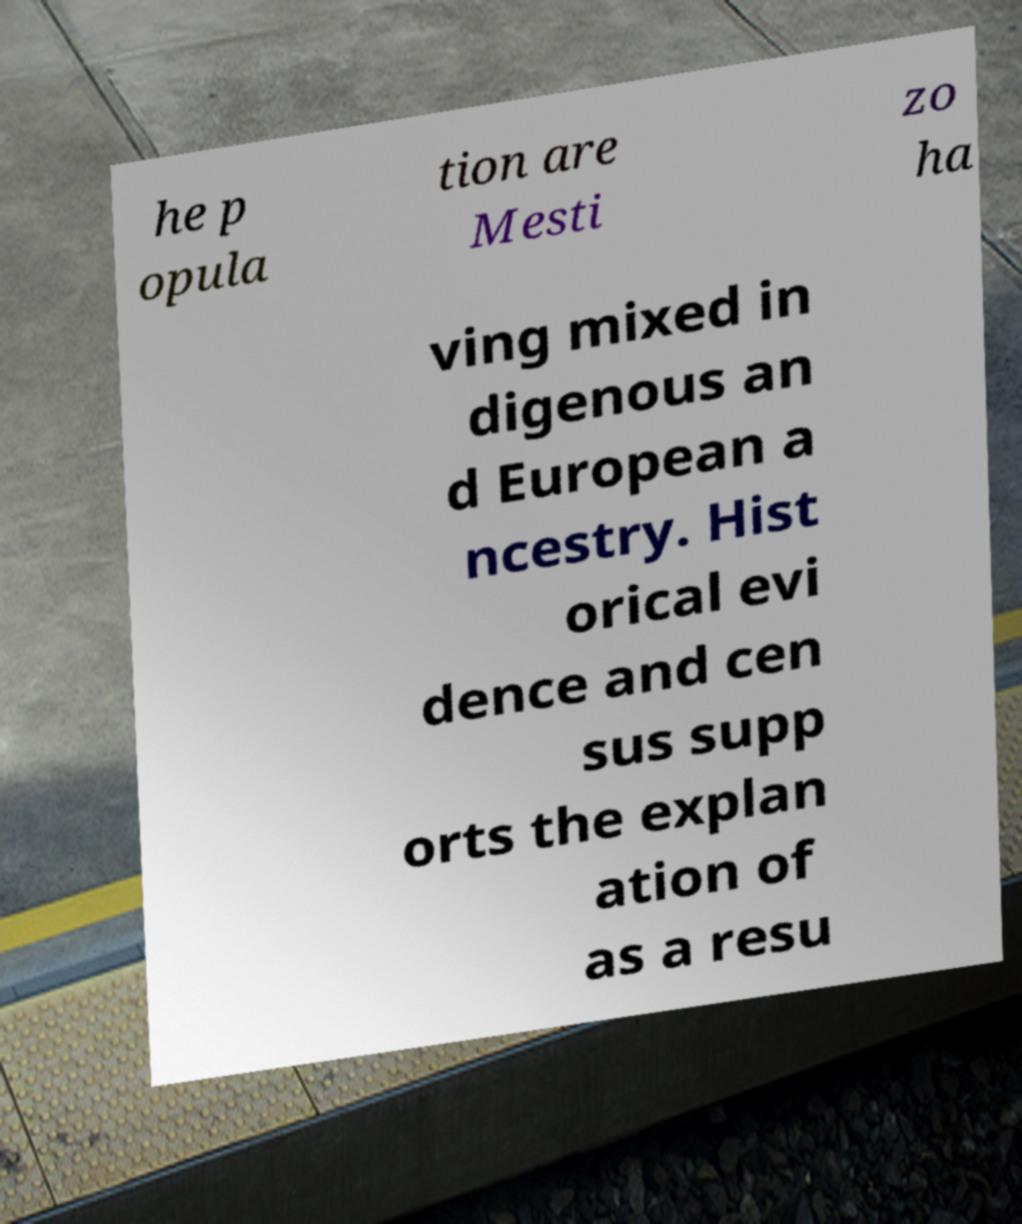Please read and relay the text visible in this image. What does it say? he p opula tion are Mesti zo ha ving mixed in digenous an d European a ncestry. Hist orical evi dence and cen sus supp orts the explan ation of as a resu 